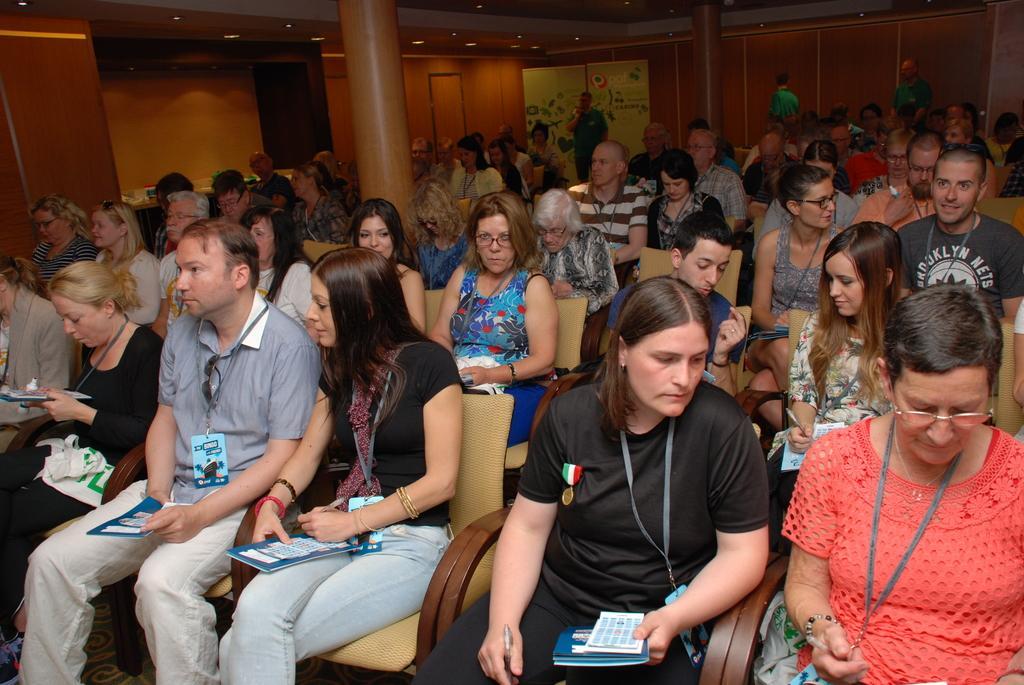Could you give a brief overview of what you see in this image? In this image I can see number of persons are sitting on chairs which are brown in color. I can see they are holding books in their hands. In the background I can see few persons standing, few pillars, the ceiling, few lights to the ceiling and a banner. 